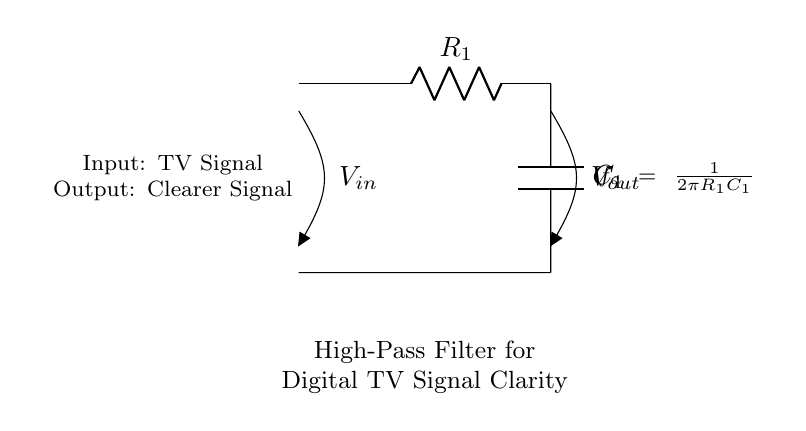What are the components of this circuit? The circuit consists of a resistor labeled R1 and a capacitor labeled C1. These are the main components utilized to form the high-pass filter.
Answer: Resistor and Capacitor What is the function of this circuit? The circuit is designed as a high-pass filter to improve the clarity of digital television signals, allowing high-frequency components to pass while attenuating low-frequency noise.
Answer: High-pass filter What does Vout represent in this circuit? Vout is the output voltage, which represents the clearer signal after filtering, ensuring that only frequencies above the cutoff frequency are transmitted.
Answer: Clearer signal What is the formula for the cutoff frequency? The cutoff frequency is given by the formula f_c = 1/(2πR1C1), where R1 is the resistance and C1 is the capacitance in the circuit.
Answer: f_c = 1/(2πR1C1) What type of filter is this circuit? This circuit is classified as a high-pass filter because it allows high frequencies to pass through while blocking lower frequencies.
Answer: High-pass filter How does the capacitor behave at high frequencies? At high frequencies, the impedance of the capacitor decreases, allowing more current to flow through, which enhances the clarity of the signal at the output.
Answer: Decreases impedance 